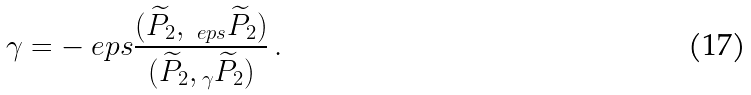<formula> <loc_0><loc_0><loc_500><loc_500>\gamma = - \ e p s \frac { ( \widetilde { P } _ { 2 } , \L _ { \ e p s } \widetilde { P } _ { 2 } ) } { ( \widetilde { P } _ { 2 } , \L _ { \gamma } \widetilde { P } _ { 2 } ) } \, .</formula> 